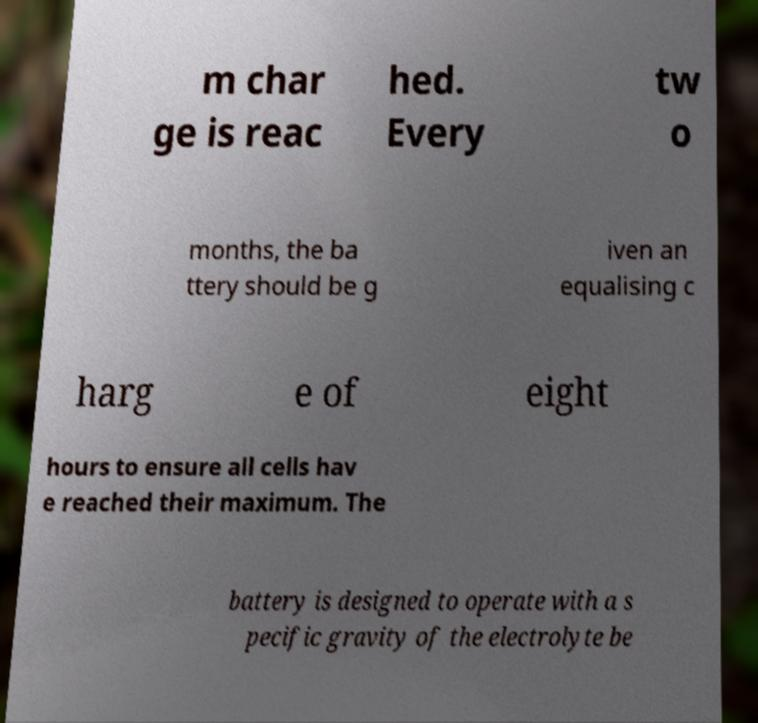I need the written content from this picture converted into text. Can you do that? m char ge is reac hed. Every tw o months, the ba ttery should be g iven an equalising c harg e of eight hours to ensure all cells hav e reached their maximum. The battery is designed to operate with a s pecific gravity of the electrolyte be 